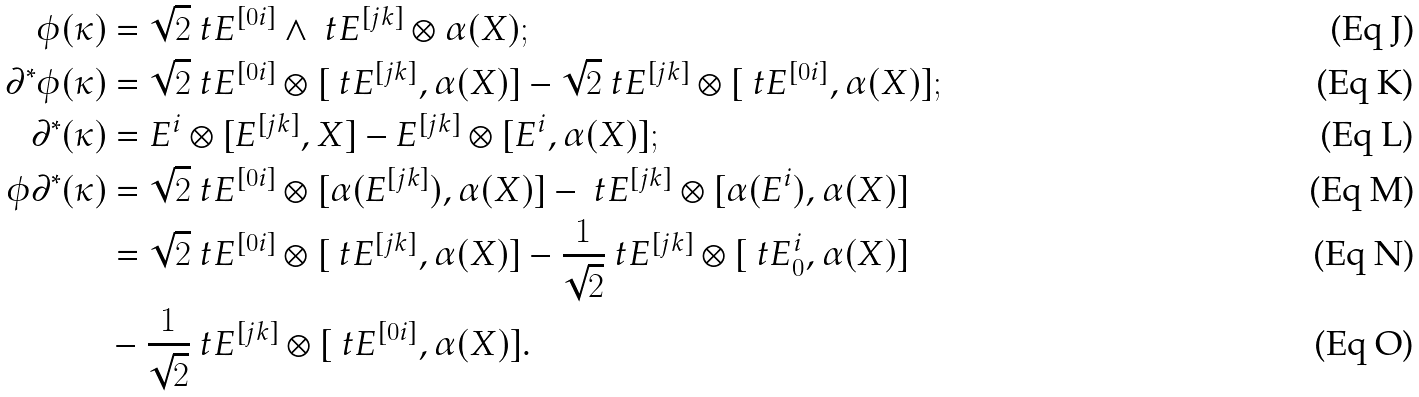Convert formula to latex. <formula><loc_0><loc_0><loc_500><loc_500>\phi ( \kappa ) & = \sqrt { 2 } \ t E ^ { [ 0 i ] } \wedge \ t E ^ { [ j k ] } \otimes \alpha ( X ) ; \\ \partial ^ { * } \phi ( \kappa ) & = \sqrt { 2 } \ t E ^ { [ 0 i ] } \otimes [ \ t E ^ { [ j k ] } , \alpha ( X ) ] - \sqrt { 2 } \ t E ^ { [ j k ] } \otimes [ \ t E ^ { [ 0 i ] } , \alpha ( X ) ] ; \\ \partial ^ { * } ( \kappa ) & = E ^ { i } \otimes [ E ^ { [ j k ] } , X ] - E ^ { [ j k ] } \otimes [ E ^ { i } , \alpha ( X ) ] ; \\ \phi \partial ^ { * } ( \kappa ) & = \sqrt { 2 } \ t E ^ { [ 0 i ] } \otimes [ \alpha ( E ^ { [ j k ] } ) , \alpha ( X ) ] - \ t E ^ { [ j k ] } \otimes [ \alpha ( E ^ { i } ) , \alpha ( X ) ] \\ & = \sqrt { 2 } \ t E ^ { [ 0 i ] } \otimes [ \ t E ^ { [ j k ] } , \alpha ( X ) ] - \frac { 1 } { \sqrt { 2 } } \ t E ^ { [ j k ] } \otimes [ \ t E ^ { i } _ { 0 } , \alpha ( X ) ] \\ & - \frac { 1 } { \sqrt { 2 } } \ t E ^ { [ j k ] } \otimes [ \ t E ^ { [ 0 i ] } , \alpha ( X ) ] .</formula> 